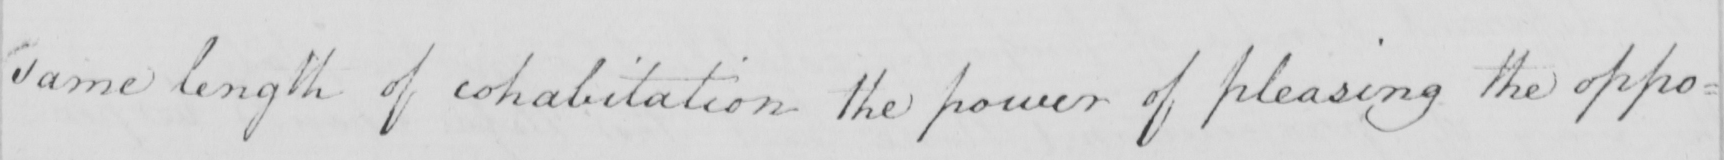Transcribe the text shown in this historical manuscript line. same length of cohabitation the power of pleasing the oppo= 